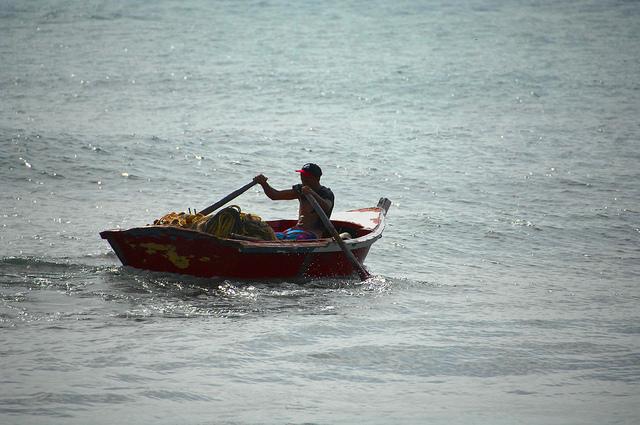Is the man wearing a baseball cap?
Quick response, please. Yes. How many boats are in this scene?
Quick response, please. 1. Is he wearing a baseball cap?
Answer briefly. Yes. 